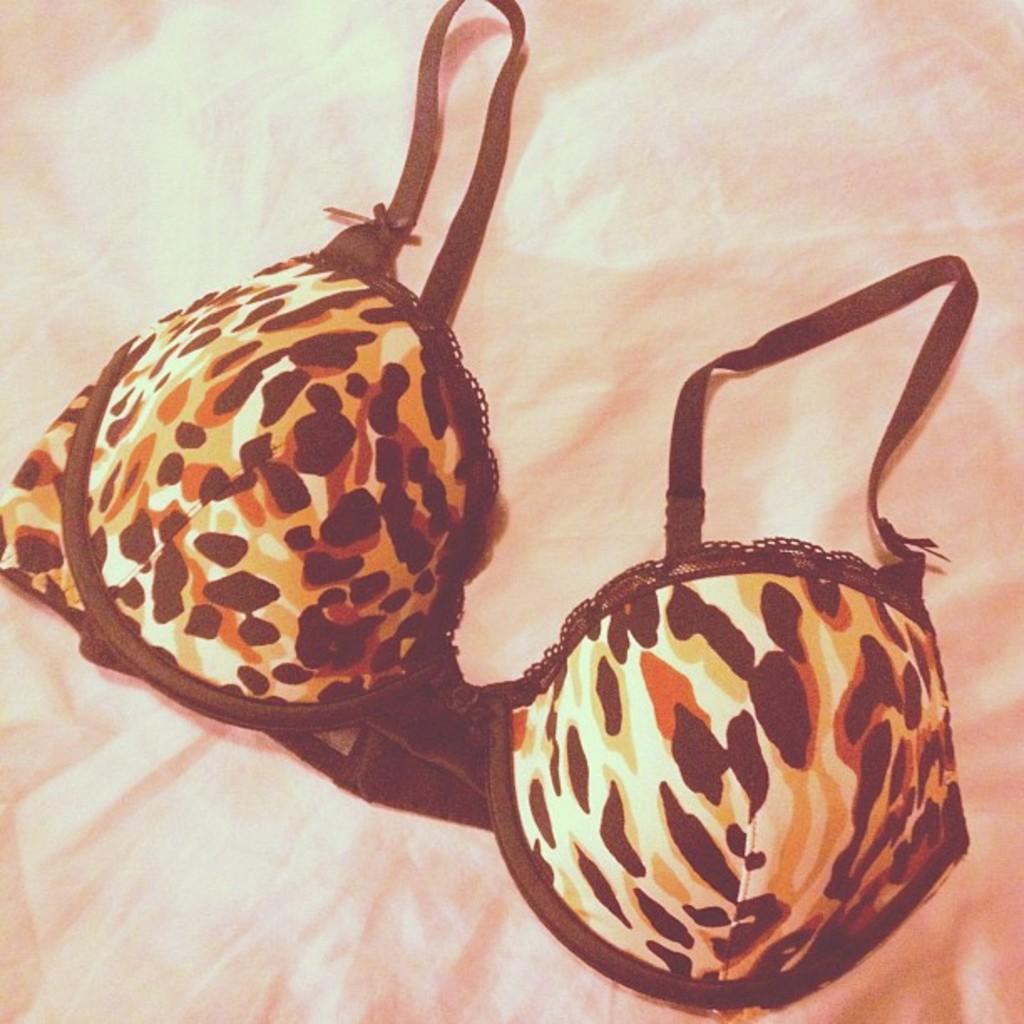In one or two sentences, can you explain what this image depicts? In this image we can see a lingerie top which is placed on the surface. 